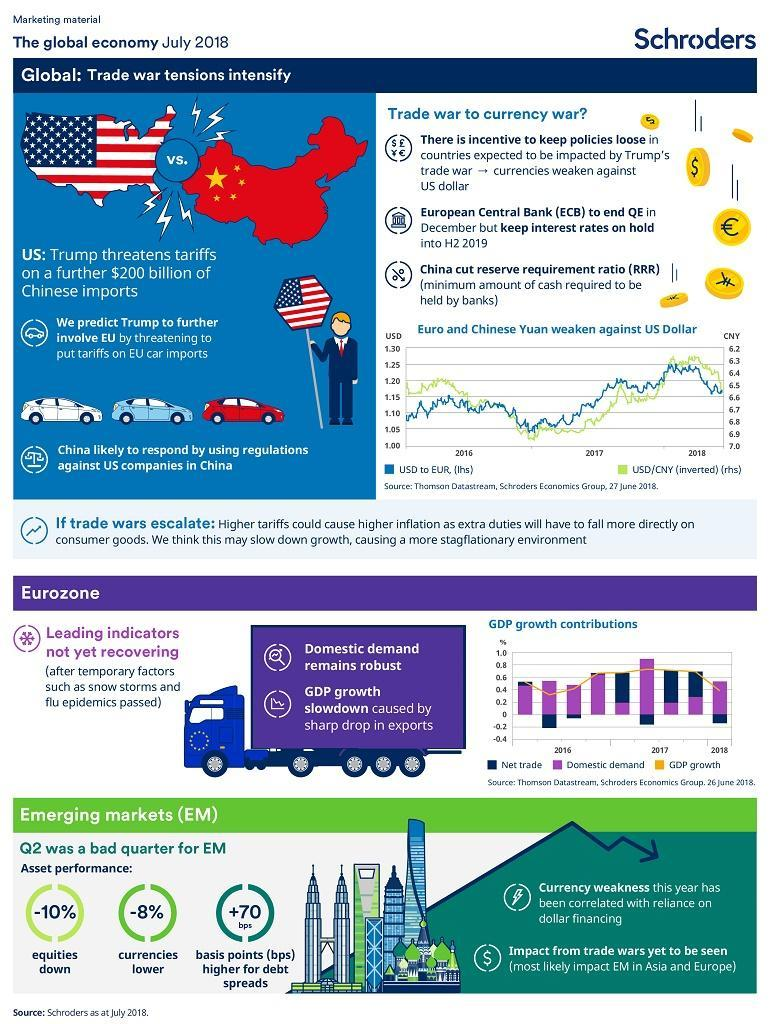By how much did currencies go lower in Q2?
Answer the question with a short phrase. 8% What was the reason for slowdown in GDP growth in Eurozone? sharp drop in exports Which temporary factors affect the economy? snow storms and flu epidemics How is Trump likely to involve EU in the trade war? threatening to put tariffs on EU car imports What has been correlated with reliance on dollar financing? Currency weakness By what percent did equities go down in Q2? 10% 